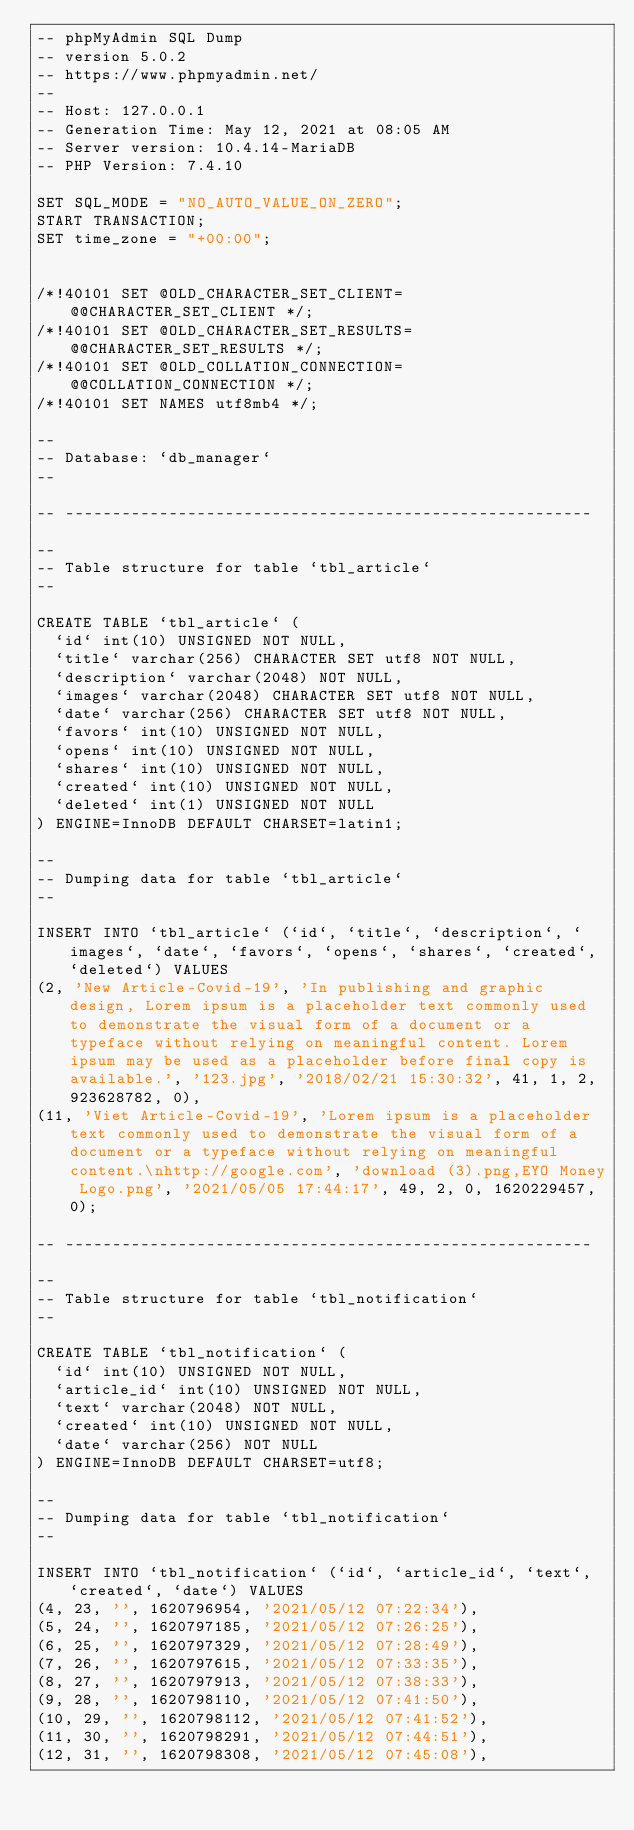Convert code to text. <code><loc_0><loc_0><loc_500><loc_500><_SQL_>-- phpMyAdmin SQL Dump
-- version 5.0.2
-- https://www.phpmyadmin.net/
--
-- Host: 127.0.0.1
-- Generation Time: May 12, 2021 at 08:05 AM
-- Server version: 10.4.14-MariaDB
-- PHP Version: 7.4.10

SET SQL_MODE = "NO_AUTO_VALUE_ON_ZERO";
START TRANSACTION;
SET time_zone = "+00:00";


/*!40101 SET @OLD_CHARACTER_SET_CLIENT=@@CHARACTER_SET_CLIENT */;
/*!40101 SET @OLD_CHARACTER_SET_RESULTS=@@CHARACTER_SET_RESULTS */;
/*!40101 SET @OLD_COLLATION_CONNECTION=@@COLLATION_CONNECTION */;
/*!40101 SET NAMES utf8mb4 */;

--
-- Database: `db_manager`
--

-- --------------------------------------------------------

--
-- Table structure for table `tbl_article`
--

CREATE TABLE `tbl_article` (
  `id` int(10) UNSIGNED NOT NULL,
  `title` varchar(256) CHARACTER SET utf8 NOT NULL,
  `description` varchar(2048) NOT NULL,
  `images` varchar(2048) CHARACTER SET utf8 NOT NULL,
  `date` varchar(256) CHARACTER SET utf8 NOT NULL,
  `favors` int(10) UNSIGNED NOT NULL,
  `opens` int(10) UNSIGNED NOT NULL,
  `shares` int(10) UNSIGNED NOT NULL,
  `created` int(10) UNSIGNED NOT NULL,
  `deleted` int(1) UNSIGNED NOT NULL
) ENGINE=InnoDB DEFAULT CHARSET=latin1;

--
-- Dumping data for table `tbl_article`
--

INSERT INTO `tbl_article` (`id`, `title`, `description`, `images`, `date`, `favors`, `opens`, `shares`, `created`, `deleted`) VALUES
(2, 'New Article-Covid-19', 'In publishing and graphic design, Lorem ipsum is a placeholder text commonly used to demonstrate the visual form of a document or a typeface without relying on meaningful content. Lorem ipsum may be used as a placeholder before final copy is available.', '123.jpg', '2018/02/21 15:30:32', 41, 1, 2, 923628782, 0),
(11, 'Viet Article-Covid-19', 'Lorem ipsum is a placeholder text commonly used to demonstrate the visual form of a document or a typeface without relying on meaningful content.\nhttp://google.com', 'download (3).png,EYO Money Logo.png', '2021/05/05 17:44:17', 49, 2, 0, 1620229457, 0);

-- --------------------------------------------------------

--
-- Table structure for table `tbl_notification`
--

CREATE TABLE `tbl_notification` (
  `id` int(10) UNSIGNED NOT NULL,
  `article_id` int(10) UNSIGNED NOT NULL,
  `text` varchar(2048) NOT NULL,
  `created` int(10) UNSIGNED NOT NULL,
  `date` varchar(256) NOT NULL
) ENGINE=InnoDB DEFAULT CHARSET=utf8;

--
-- Dumping data for table `tbl_notification`
--

INSERT INTO `tbl_notification` (`id`, `article_id`, `text`, `created`, `date`) VALUES
(4, 23, '', 1620796954, '2021/05/12 07:22:34'),
(5, 24, '', 1620797185, '2021/05/12 07:26:25'),
(6, 25, '', 1620797329, '2021/05/12 07:28:49'),
(7, 26, '', 1620797615, '2021/05/12 07:33:35'),
(8, 27, '', 1620797913, '2021/05/12 07:38:33'),
(9, 28, '', 1620798110, '2021/05/12 07:41:50'),
(10, 29, '', 1620798112, '2021/05/12 07:41:52'),
(11, 30, '', 1620798291, '2021/05/12 07:44:51'),
(12, 31, '', 1620798308, '2021/05/12 07:45:08'),</code> 